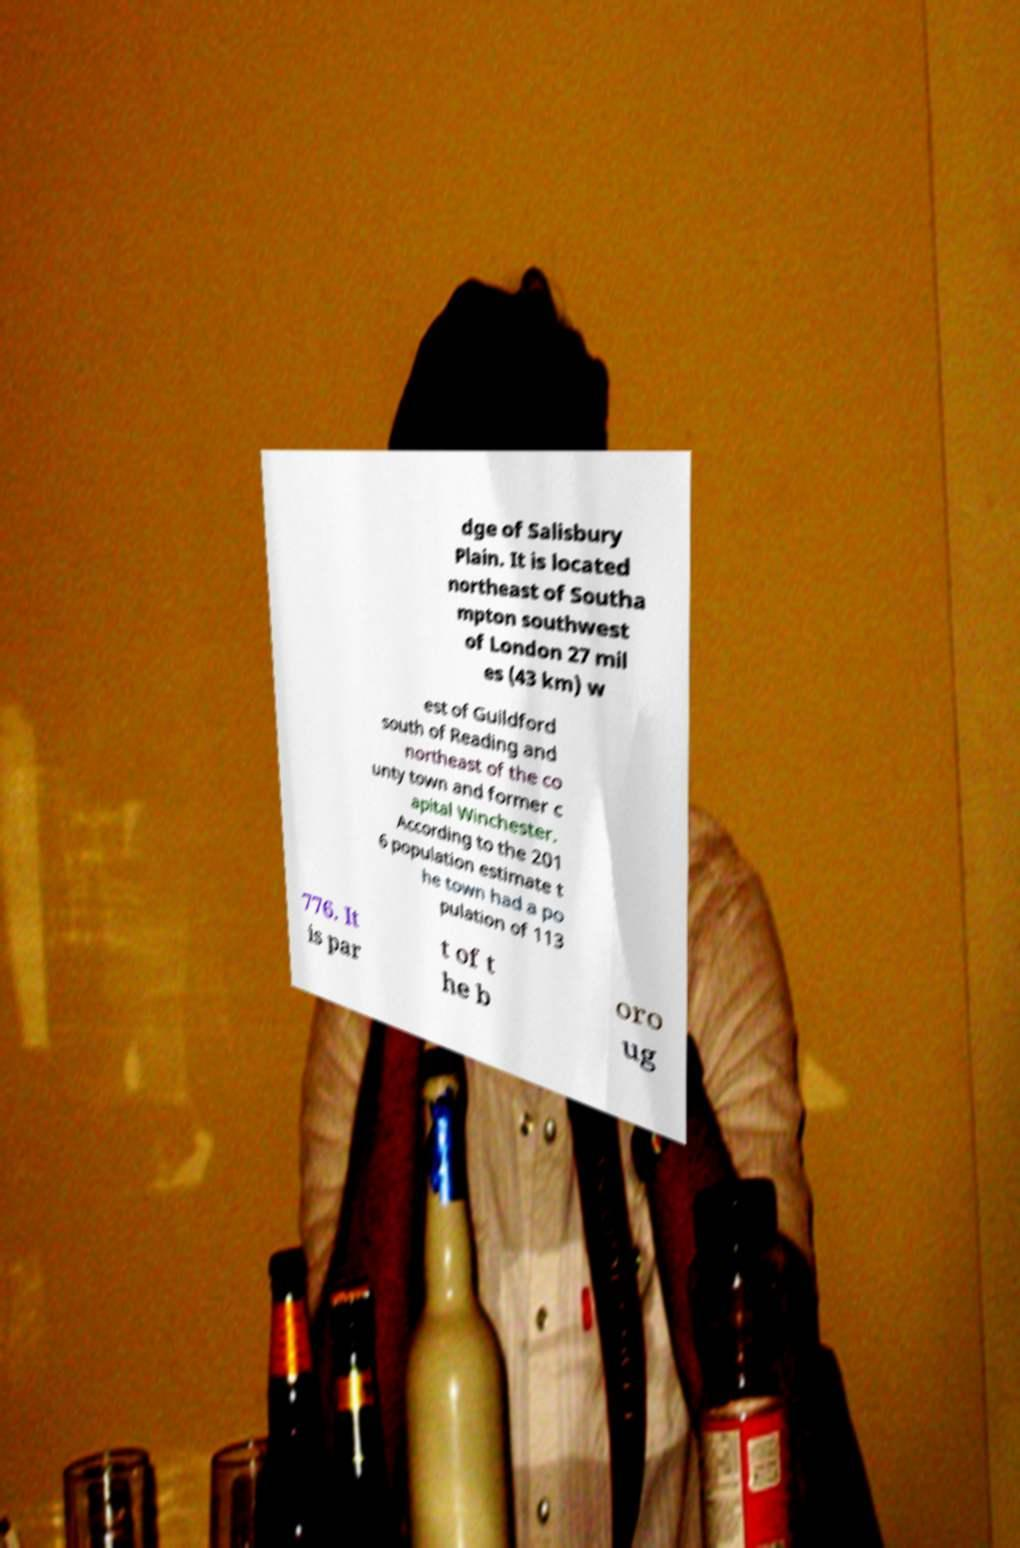I need the written content from this picture converted into text. Can you do that? dge of Salisbury Plain. It is located northeast of Southa mpton southwest of London 27 mil es (43 km) w est of Guildford south of Reading and northeast of the co unty town and former c apital Winchester. According to the 201 6 population estimate t he town had a po pulation of 113 776. It is par t of t he b oro ug 